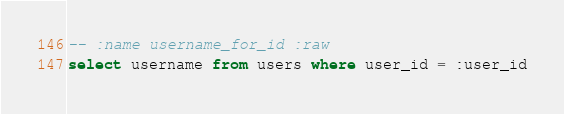Convert code to text. <code><loc_0><loc_0><loc_500><loc_500><_SQL_>-- :name username_for_id :raw
select username from users where user_id = :user_id
</code> 